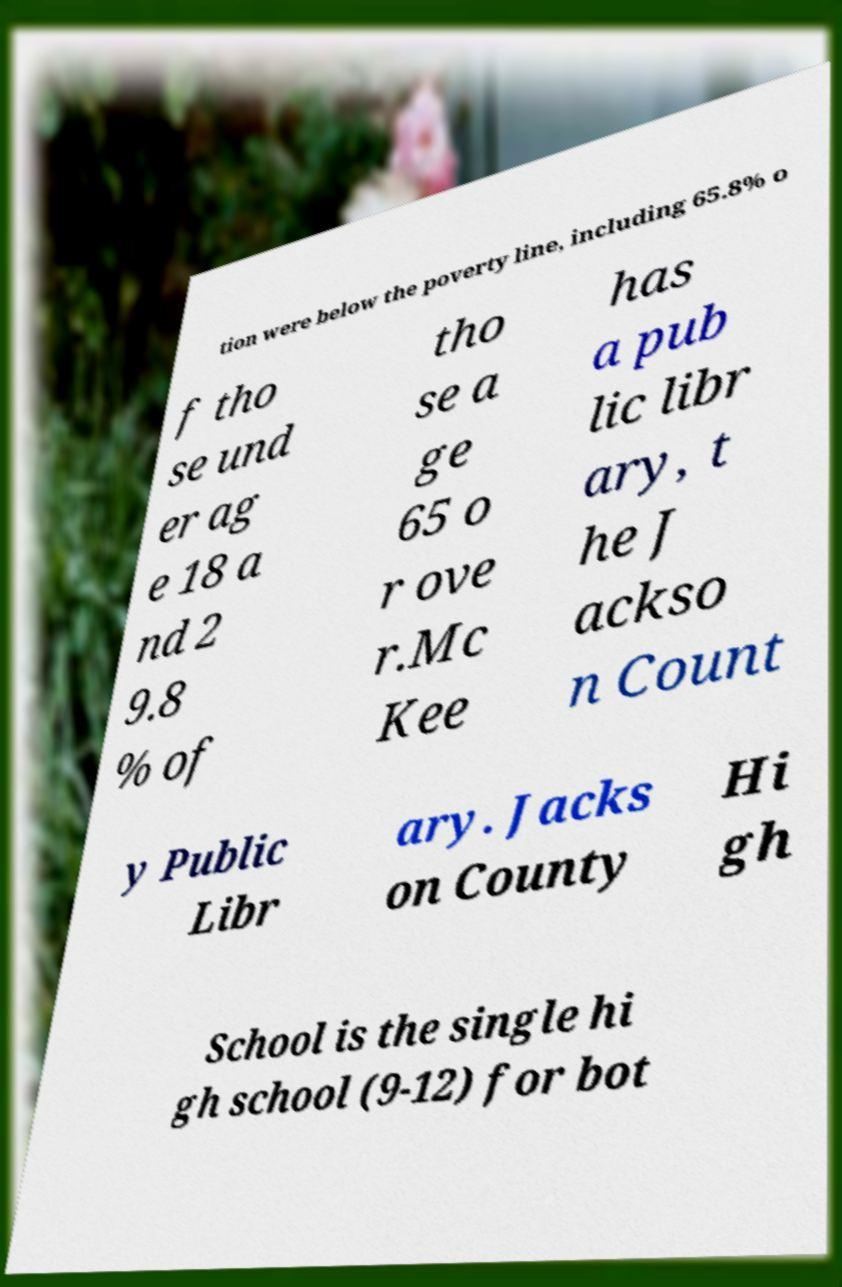What messages or text are displayed in this image? I need them in a readable, typed format. tion were below the poverty line, including 65.8% o f tho se und er ag e 18 a nd 2 9.8 % of tho se a ge 65 o r ove r.Mc Kee has a pub lic libr ary, t he J ackso n Count y Public Libr ary. Jacks on County Hi gh School is the single hi gh school (9-12) for bot 